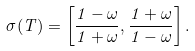<formula> <loc_0><loc_0><loc_500><loc_500>\sigma ( { T } ) = \left [ \frac { 1 - \omega } { 1 + \omega } , \frac { 1 + \omega } { 1 - \omega } \right ] .</formula> 